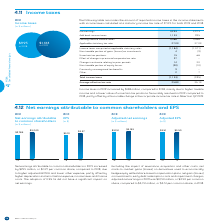According to Bce's financial document, What was the statutory income tax rate used for both 2019 and 2018? According to the financial document, 27.0%. The relevant text states: "Applicable statutory tax rate 27.0% 27.0%..." Also, What was the main factor that led to the increase in income taxes in 2019? higher taxable income and a lower value of uncertain tax positions favourably resolved in 2019 compared to 2018, partly offset by a favourable change in the corporate income tax rate in Alberta in Q2 2019. The document states: "by $138 million, compared to 2018, mainly due to higher taxable income and a lower value of uncertain tax positions favourably resolved in 2019 compar..." Also, What are the net earnings for 2019? According to the financial document, 3,253. The relevant text states: "Net earnings 3,253 2,973..." Also, can you calculate: What is the change in the applicable statutory tax rate from 2018 to 2019? I cannot find a specific answer to this question in the financial document. Also, can you calculate: What is the percentage change in the earnings before income taxes from 2018 to 2019? To answer this question, I need to perform calculations using the financial data. The calculation is: (4,386-3,968)/3,968, which equals 10.53 (percentage). This is based on the information: "Earnings before income taxes 4,386 3,968 Earnings before income taxes 4,386 3,968..." The key data points involved are: 3,968, 4,386. Also, can you calculate: What is the total amount of uncertain tax positions in 2018 and 2019? Based on the calculation: 15+68, the result is 83. This is based on the information: "Uncertain tax positions 15 68 Uncertain tax positions 15 68..." The key data points involved are: 15, 68. 